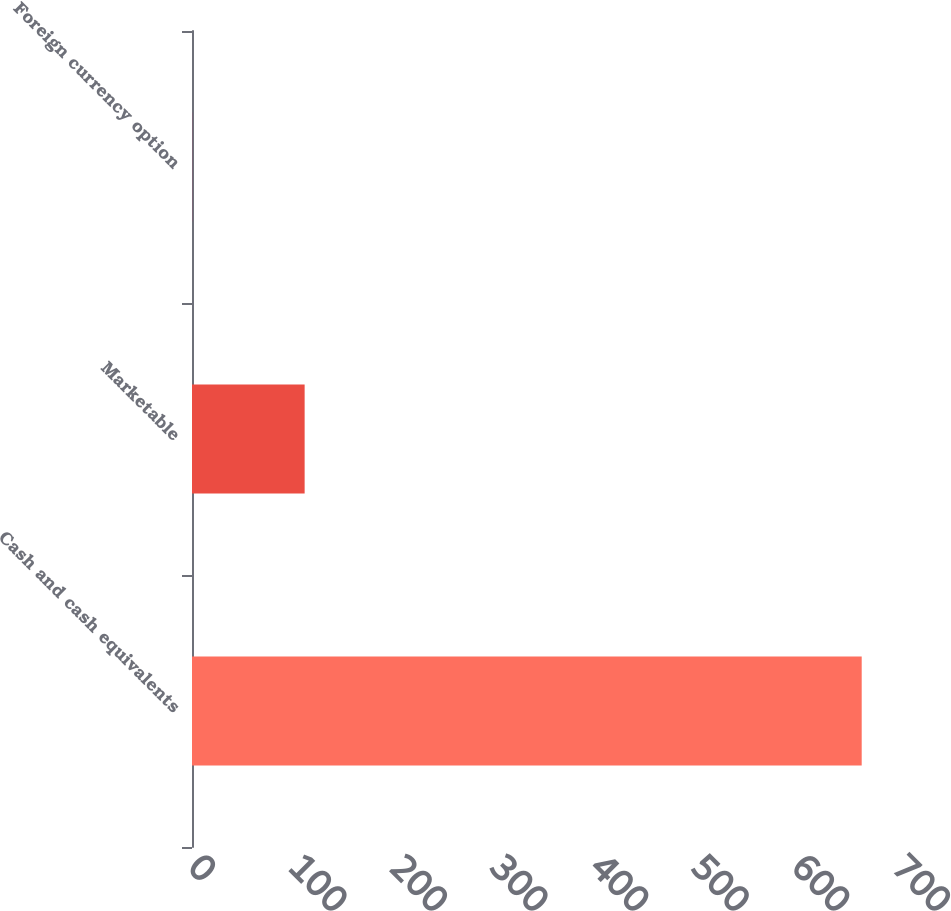Convert chart. <chart><loc_0><loc_0><loc_500><loc_500><bar_chart><fcel>Cash and cash equivalents<fcel>Marketable<fcel>Foreign currency option<nl><fcel>665.9<fcel>112<fcel>0.1<nl></chart> 